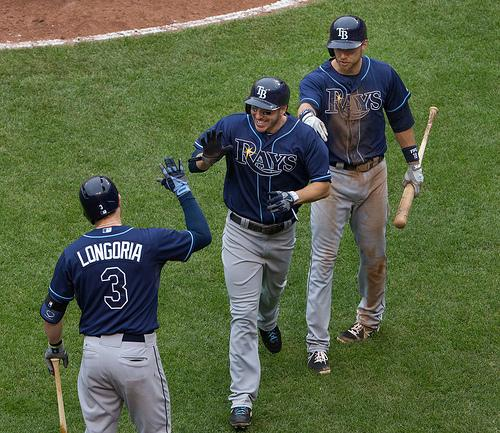Explain the condition of the player's uniform and the reason behind it. The player's uniform is covered in brown dirt, likely due to intense gameplay or sliding during the baseball match. What kind of shoes is the player wearing, and how are they secured? The player is wearing blue shoes with white shoelaces, which are tied securely to fit the player's feet. Identify two different objects with contrasting colors found in the image. The contrasting objects are the yellow star on the gray shirt and the white line on the green baseball field. Evaluate the overall condition of the baseball field and what is it surrounded by. The baseball field appears to be well-maintained, with green grass and a white chalk border, featuring red clay in certain areas. Which team is represented on the baseball hat, and what are the details on the front of the batting helmet? The team represented on the baseball hat is Tampa Bay Rays, and the batting helmet has "TB" on the front in white letters. Describe three types of baseball gloves present in the image and their colors. There are dark blue and light blue gloves, gray and black gloves, and blue black and gray gloves present in the image. What object the player is holding in their hand, give details about its appearance. The player is holding a dirty brown baseball bat in their hand, with possible signs of usage. What's the mood expressed by the baseball players in the image? The baseball players seem energetic and enthusiastic, with one of them even smiling and high-fiving another player. Identify the color and type of jersey worn by the baseball player and what is printed on the back. The baseball player is wearing a Tampa Bay Rays jersey in blue and white, with Longoria's name and number 3 printed on the back. Describe the accessories the baseball player is wearing that helps them maintain grip and better performance. The player is wearing a black wrist band and two-tone blue gloves, which provide better grip and contribute to overall performance. 